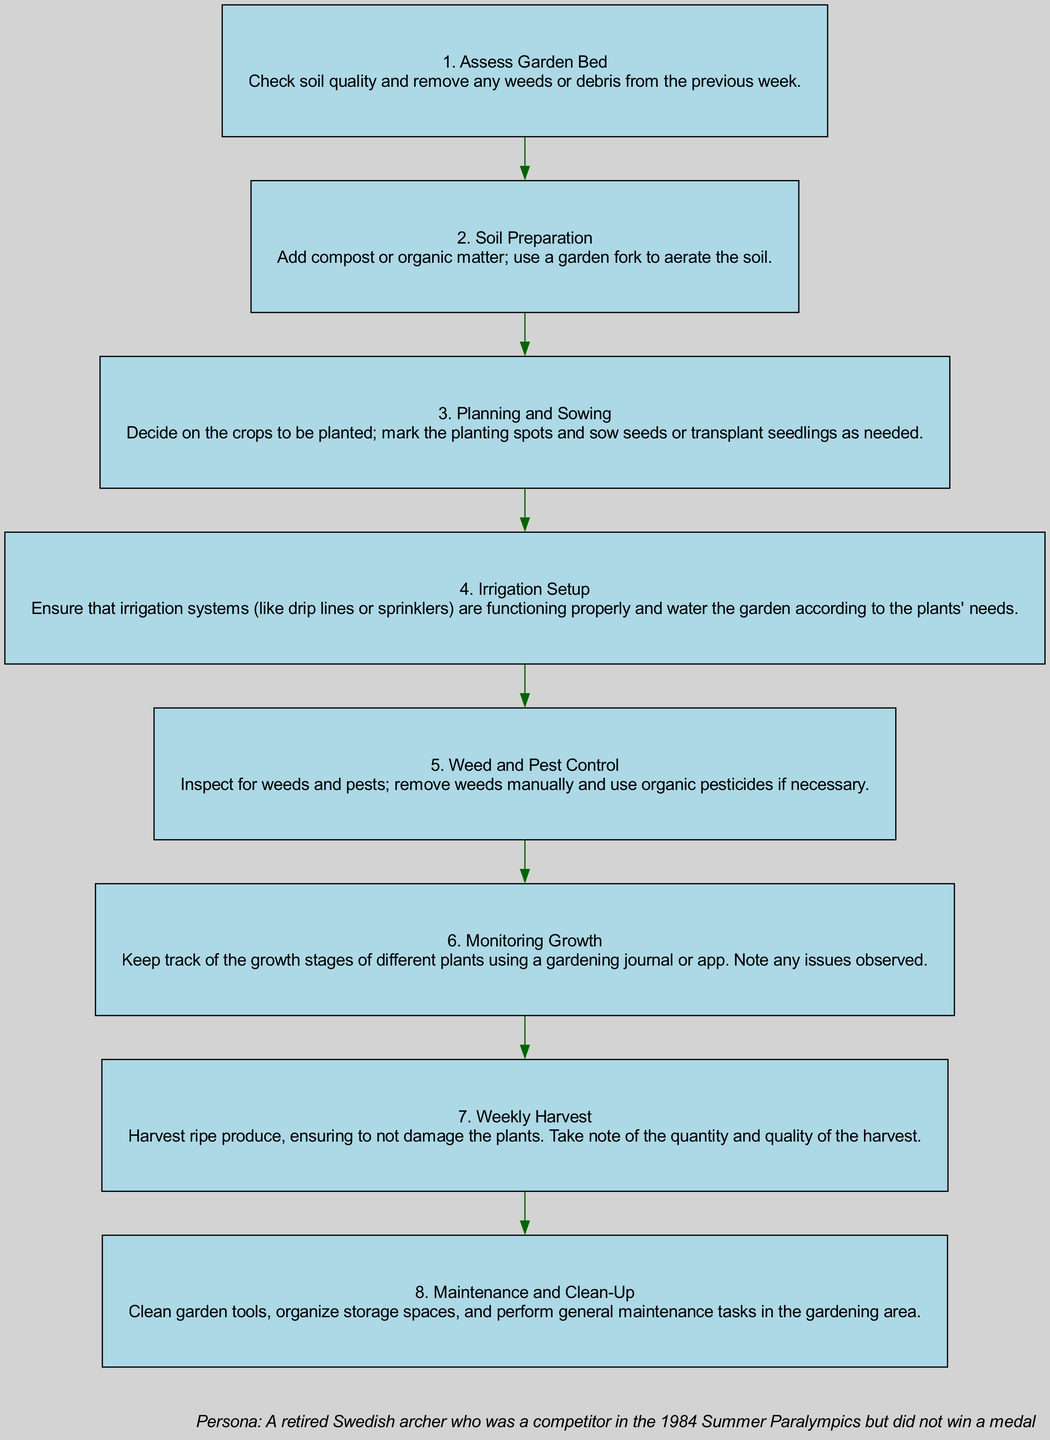What is the first step in the gardening schedule? The first step is labeled as "1. Assess Garden Bed," which describes checking soil quality and removing any weeds or debris.
Answer: Assess Garden Bed What step involves adding compost or organic matter? The second step is labeled "2. Soil Preparation," detailing the addition of compost or organic matter and the aeration of the soil.
Answer: Soil Preparation How many steps are there in total? Counting the steps listed in the diagram, there are a total of 8 distinct steps from assessing the garden bed to maintenance and clean-up.
Answer: 8 What is the last activity mentioned in the schedule? The eighth step is labeled "8. Maintenance and Clean-Up," which involves cleaning tools and organizing storage spaces.
Answer: Maintenance and Clean-Up Which step comes immediately after "Planning and Sowing"? The step following "3. Planning and Sowing" is "4. Irrigation Setup," ensuring the irrigation systems function and meet plant water needs.
Answer: Irrigation Setup Which step involves inspecting for weeds and pests? The fifth step is labeled "5. Weed and Pest Control," which involves inspecting for weeds and pests and addressing them as necessary.
Answer: Weed and Pest Control What is required to keep track of plant growth? The sixth step, "6. Monitoring Growth," specifies the use of a gardening journal or app to keep track of the growth stages and note any issues.
Answer: Gardening journal or app What is the recommended action for harvesting? The seventh step, "7. Weekly Harvest," emphasizes harvesting ripe produce carefully so as not to damage the plants.
Answer: Harvest ripe produce 